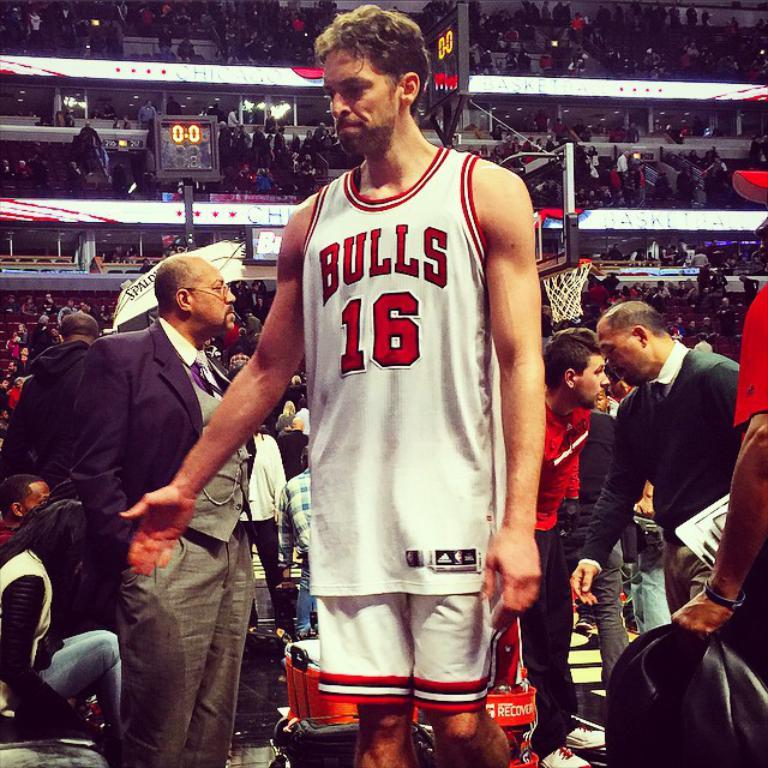What basketball team does number sixteen play for?
Your response must be concise. Bulls. What is this player's jersey number?
Give a very brief answer. 16. 